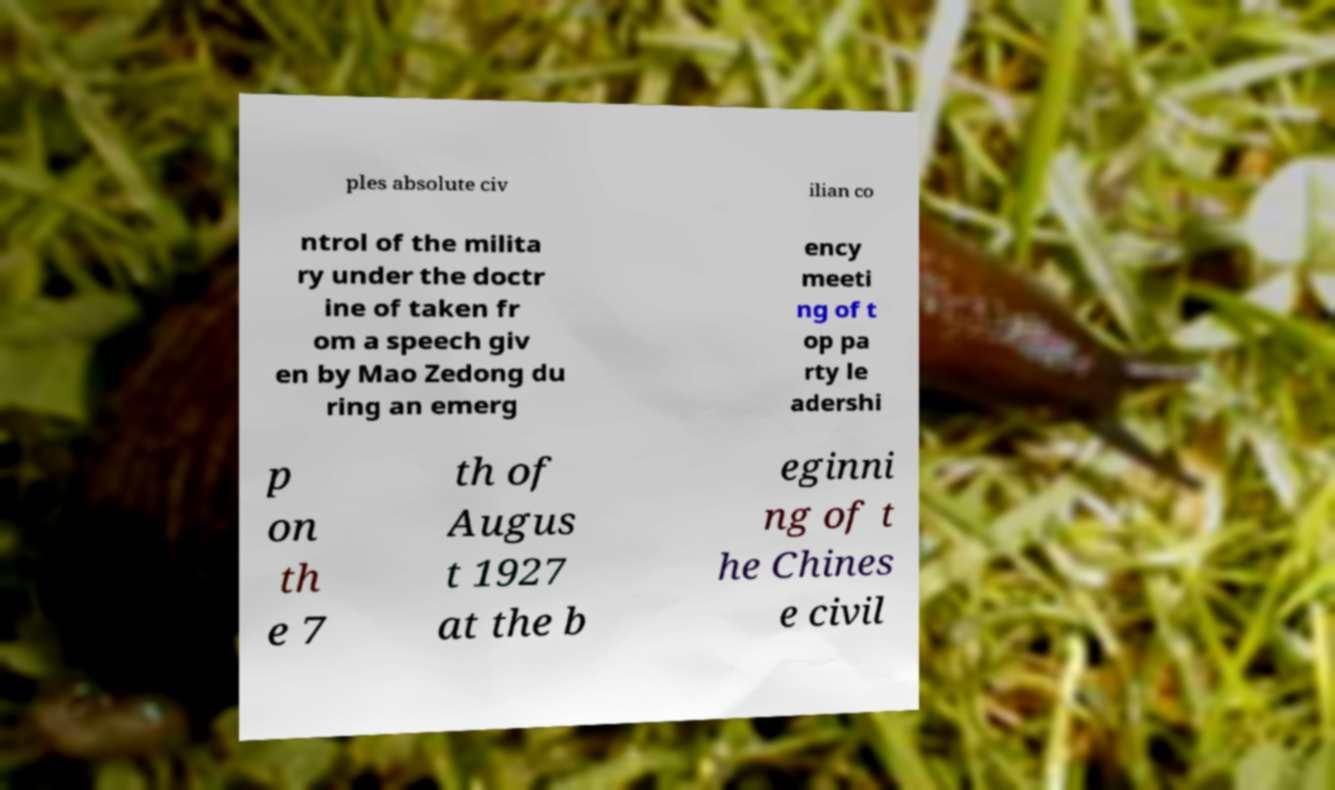Can you read and provide the text displayed in the image?This photo seems to have some interesting text. Can you extract and type it out for me? ples absolute civ ilian co ntrol of the milita ry under the doctr ine of taken fr om a speech giv en by Mao Zedong du ring an emerg ency meeti ng of t op pa rty le adershi p on th e 7 th of Augus t 1927 at the b eginni ng of t he Chines e civil 